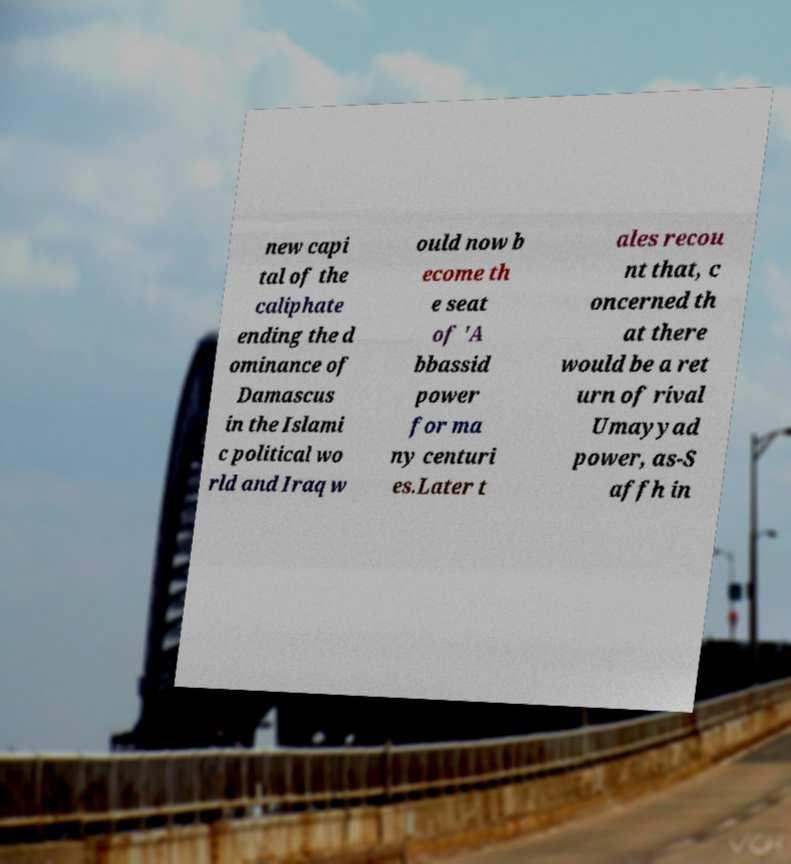I need the written content from this picture converted into text. Can you do that? new capi tal of the caliphate ending the d ominance of Damascus in the Islami c political wo rld and Iraq w ould now b ecome th e seat of 'A bbassid power for ma ny centuri es.Later t ales recou nt that, c oncerned th at there would be a ret urn of rival Umayyad power, as-S affh in 